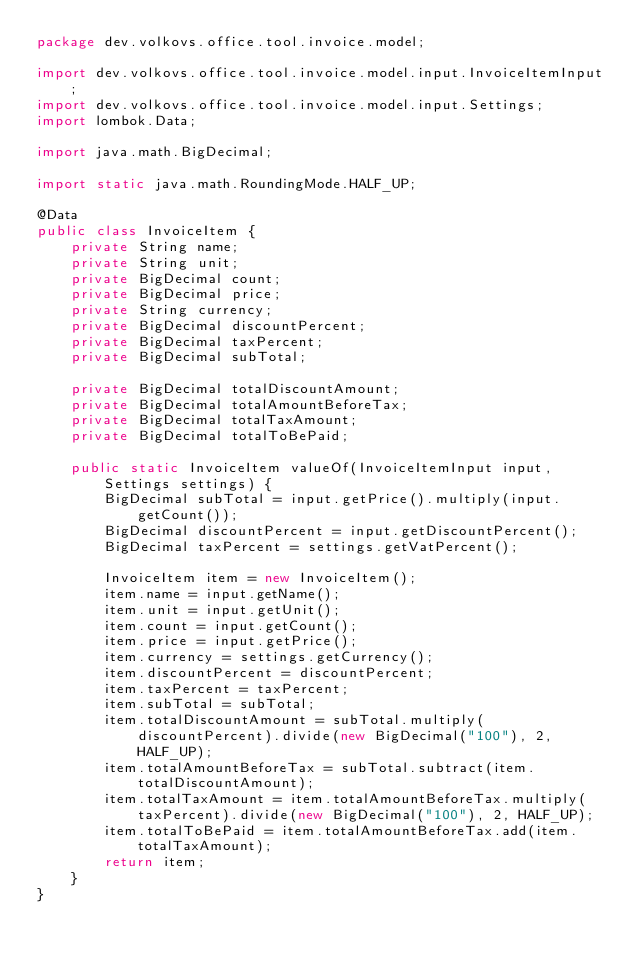Convert code to text. <code><loc_0><loc_0><loc_500><loc_500><_Java_>package dev.volkovs.office.tool.invoice.model;

import dev.volkovs.office.tool.invoice.model.input.InvoiceItemInput;
import dev.volkovs.office.tool.invoice.model.input.Settings;
import lombok.Data;

import java.math.BigDecimal;

import static java.math.RoundingMode.HALF_UP;

@Data
public class InvoiceItem {
    private String name;
    private String unit;
    private BigDecimal count;
    private BigDecimal price;
    private String currency;
    private BigDecimal discountPercent;
    private BigDecimal taxPercent;
    private BigDecimal subTotal;

    private BigDecimal totalDiscountAmount;
    private BigDecimal totalAmountBeforeTax;
    private BigDecimal totalTaxAmount;
    private BigDecimal totalToBePaid;

    public static InvoiceItem valueOf(InvoiceItemInput input, Settings settings) {
        BigDecimal subTotal = input.getPrice().multiply(input.getCount());
        BigDecimal discountPercent = input.getDiscountPercent();
        BigDecimal taxPercent = settings.getVatPercent();

        InvoiceItem item = new InvoiceItem();
        item.name = input.getName();
        item.unit = input.getUnit();
        item.count = input.getCount();
        item.price = input.getPrice();
        item.currency = settings.getCurrency();
        item.discountPercent = discountPercent;
        item.taxPercent = taxPercent;
        item.subTotal = subTotal;
        item.totalDiscountAmount = subTotal.multiply(discountPercent).divide(new BigDecimal("100"), 2, HALF_UP);
        item.totalAmountBeforeTax = subTotal.subtract(item.totalDiscountAmount);
        item.totalTaxAmount = item.totalAmountBeforeTax.multiply(taxPercent).divide(new BigDecimal("100"), 2, HALF_UP);
        item.totalToBePaid = item.totalAmountBeforeTax.add(item.totalTaxAmount);
        return item;
    }
}
</code> 